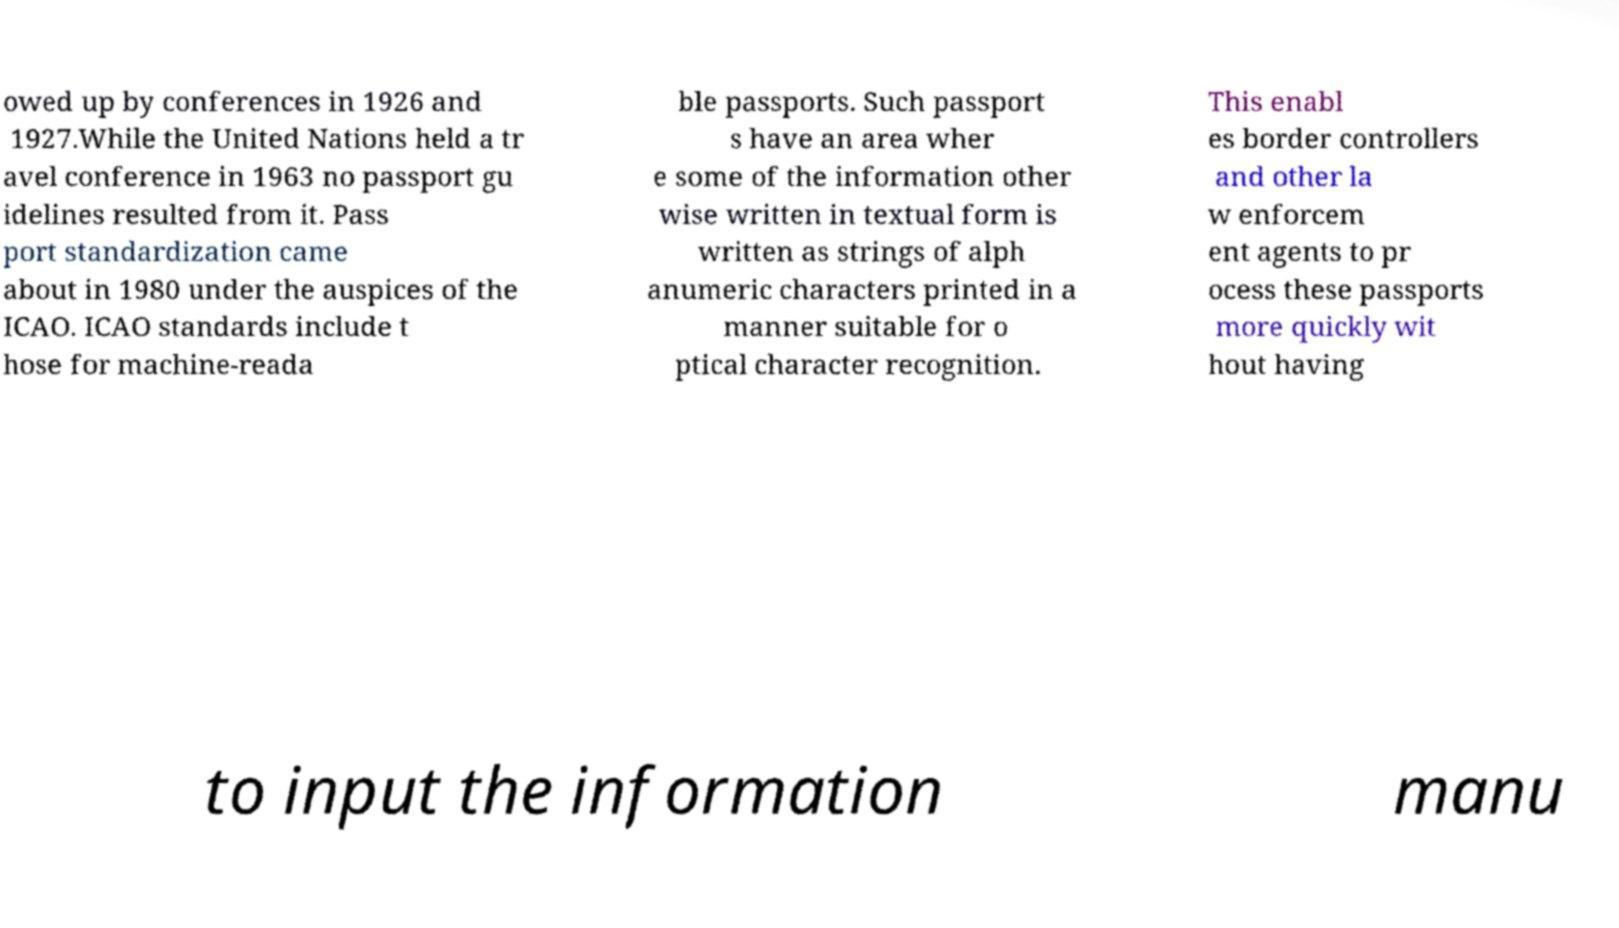For documentation purposes, I need the text within this image transcribed. Could you provide that? owed up by conferences in 1926 and 1927.While the United Nations held a tr avel conference in 1963 no passport gu idelines resulted from it. Pass port standardization came about in 1980 under the auspices of the ICAO. ICAO standards include t hose for machine-reada ble passports. Such passport s have an area wher e some of the information other wise written in textual form is written as strings of alph anumeric characters printed in a manner suitable for o ptical character recognition. This enabl es border controllers and other la w enforcem ent agents to pr ocess these passports more quickly wit hout having to input the information manu 